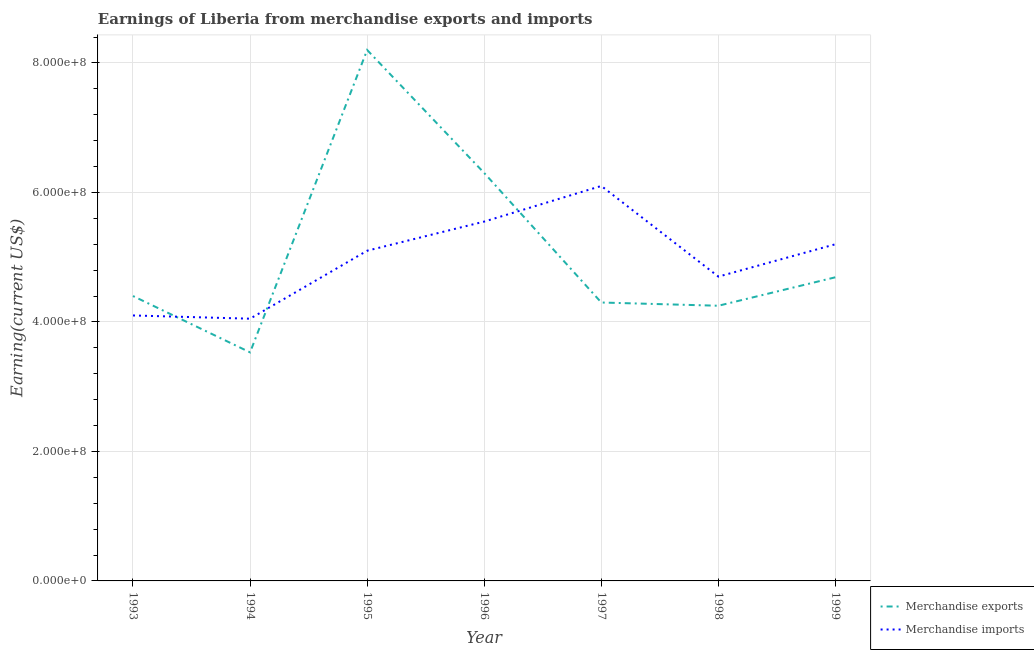How many different coloured lines are there?
Your response must be concise. 2. Is the number of lines equal to the number of legend labels?
Provide a short and direct response. Yes. What is the earnings from merchandise imports in 1993?
Provide a short and direct response. 4.10e+08. Across all years, what is the maximum earnings from merchandise exports?
Your answer should be compact. 8.20e+08. Across all years, what is the minimum earnings from merchandise imports?
Ensure brevity in your answer.  4.05e+08. In which year was the earnings from merchandise exports minimum?
Your response must be concise. 1994. What is the total earnings from merchandise imports in the graph?
Offer a terse response. 3.48e+09. What is the difference between the earnings from merchandise exports in 1997 and that in 1998?
Offer a very short reply. 5.00e+06. What is the difference between the earnings from merchandise imports in 1993 and the earnings from merchandise exports in 1995?
Ensure brevity in your answer.  -4.10e+08. What is the average earnings from merchandise imports per year?
Give a very brief answer. 4.97e+08. In the year 1998, what is the difference between the earnings from merchandise exports and earnings from merchandise imports?
Provide a short and direct response. -4.50e+07. In how many years, is the earnings from merchandise exports greater than 640000000 US$?
Your answer should be very brief. 1. What is the ratio of the earnings from merchandise exports in 1994 to that in 1999?
Provide a succinct answer. 0.75. What is the difference between the highest and the second highest earnings from merchandise imports?
Your answer should be compact. 5.50e+07. What is the difference between the highest and the lowest earnings from merchandise imports?
Your answer should be compact. 2.05e+08. In how many years, is the earnings from merchandise imports greater than the average earnings from merchandise imports taken over all years?
Ensure brevity in your answer.  4. Does the earnings from merchandise exports monotonically increase over the years?
Provide a succinct answer. No. Is the earnings from merchandise exports strictly less than the earnings from merchandise imports over the years?
Offer a very short reply. No. What is the difference between two consecutive major ticks on the Y-axis?
Offer a very short reply. 2.00e+08. Are the values on the major ticks of Y-axis written in scientific E-notation?
Offer a very short reply. Yes. Does the graph contain any zero values?
Your answer should be compact. No. Does the graph contain grids?
Give a very brief answer. Yes. Where does the legend appear in the graph?
Give a very brief answer. Bottom right. What is the title of the graph?
Your response must be concise. Earnings of Liberia from merchandise exports and imports. Does "Rural Population" appear as one of the legend labels in the graph?
Give a very brief answer. No. What is the label or title of the Y-axis?
Keep it short and to the point. Earning(current US$). What is the Earning(current US$) of Merchandise exports in 1993?
Give a very brief answer. 4.40e+08. What is the Earning(current US$) in Merchandise imports in 1993?
Your response must be concise. 4.10e+08. What is the Earning(current US$) of Merchandise exports in 1994?
Ensure brevity in your answer.  3.53e+08. What is the Earning(current US$) in Merchandise imports in 1994?
Provide a short and direct response. 4.05e+08. What is the Earning(current US$) in Merchandise exports in 1995?
Your response must be concise. 8.20e+08. What is the Earning(current US$) in Merchandise imports in 1995?
Offer a terse response. 5.10e+08. What is the Earning(current US$) of Merchandise exports in 1996?
Provide a short and direct response. 6.30e+08. What is the Earning(current US$) in Merchandise imports in 1996?
Ensure brevity in your answer.  5.55e+08. What is the Earning(current US$) of Merchandise exports in 1997?
Provide a succinct answer. 4.30e+08. What is the Earning(current US$) in Merchandise imports in 1997?
Your response must be concise. 6.10e+08. What is the Earning(current US$) in Merchandise exports in 1998?
Your answer should be very brief. 4.25e+08. What is the Earning(current US$) of Merchandise imports in 1998?
Give a very brief answer. 4.70e+08. What is the Earning(current US$) in Merchandise exports in 1999?
Offer a terse response. 4.69e+08. What is the Earning(current US$) of Merchandise imports in 1999?
Give a very brief answer. 5.20e+08. Across all years, what is the maximum Earning(current US$) in Merchandise exports?
Offer a very short reply. 8.20e+08. Across all years, what is the maximum Earning(current US$) in Merchandise imports?
Your answer should be compact. 6.10e+08. Across all years, what is the minimum Earning(current US$) of Merchandise exports?
Offer a terse response. 3.53e+08. Across all years, what is the minimum Earning(current US$) in Merchandise imports?
Your response must be concise. 4.05e+08. What is the total Earning(current US$) of Merchandise exports in the graph?
Your answer should be very brief. 3.57e+09. What is the total Earning(current US$) in Merchandise imports in the graph?
Make the answer very short. 3.48e+09. What is the difference between the Earning(current US$) of Merchandise exports in 1993 and that in 1994?
Give a very brief answer. 8.70e+07. What is the difference between the Earning(current US$) in Merchandise imports in 1993 and that in 1994?
Provide a succinct answer. 5.00e+06. What is the difference between the Earning(current US$) in Merchandise exports in 1993 and that in 1995?
Offer a terse response. -3.80e+08. What is the difference between the Earning(current US$) in Merchandise imports in 1993 and that in 1995?
Offer a very short reply. -1.00e+08. What is the difference between the Earning(current US$) in Merchandise exports in 1993 and that in 1996?
Your answer should be compact. -1.90e+08. What is the difference between the Earning(current US$) of Merchandise imports in 1993 and that in 1996?
Offer a terse response. -1.45e+08. What is the difference between the Earning(current US$) in Merchandise imports in 1993 and that in 1997?
Give a very brief answer. -2.00e+08. What is the difference between the Earning(current US$) in Merchandise exports in 1993 and that in 1998?
Offer a terse response. 1.50e+07. What is the difference between the Earning(current US$) in Merchandise imports in 1993 and that in 1998?
Provide a succinct answer. -6.00e+07. What is the difference between the Earning(current US$) of Merchandise exports in 1993 and that in 1999?
Ensure brevity in your answer.  -2.90e+07. What is the difference between the Earning(current US$) in Merchandise imports in 1993 and that in 1999?
Provide a short and direct response. -1.10e+08. What is the difference between the Earning(current US$) in Merchandise exports in 1994 and that in 1995?
Keep it short and to the point. -4.67e+08. What is the difference between the Earning(current US$) of Merchandise imports in 1994 and that in 1995?
Make the answer very short. -1.05e+08. What is the difference between the Earning(current US$) in Merchandise exports in 1994 and that in 1996?
Provide a succinct answer. -2.77e+08. What is the difference between the Earning(current US$) of Merchandise imports in 1994 and that in 1996?
Your answer should be compact. -1.50e+08. What is the difference between the Earning(current US$) of Merchandise exports in 1994 and that in 1997?
Provide a short and direct response. -7.70e+07. What is the difference between the Earning(current US$) of Merchandise imports in 1994 and that in 1997?
Offer a terse response. -2.05e+08. What is the difference between the Earning(current US$) of Merchandise exports in 1994 and that in 1998?
Your response must be concise. -7.20e+07. What is the difference between the Earning(current US$) of Merchandise imports in 1994 and that in 1998?
Provide a succinct answer. -6.50e+07. What is the difference between the Earning(current US$) in Merchandise exports in 1994 and that in 1999?
Provide a short and direct response. -1.16e+08. What is the difference between the Earning(current US$) in Merchandise imports in 1994 and that in 1999?
Provide a short and direct response. -1.15e+08. What is the difference between the Earning(current US$) in Merchandise exports in 1995 and that in 1996?
Give a very brief answer. 1.90e+08. What is the difference between the Earning(current US$) of Merchandise imports in 1995 and that in 1996?
Make the answer very short. -4.50e+07. What is the difference between the Earning(current US$) of Merchandise exports in 1995 and that in 1997?
Give a very brief answer. 3.90e+08. What is the difference between the Earning(current US$) in Merchandise imports in 1995 and that in 1997?
Provide a succinct answer. -1.00e+08. What is the difference between the Earning(current US$) in Merchandise exports in 1995 and that in 1998?
Your answer should be compact. 3.95e+08. What is the difference between the Earning(current US$) in Merchandise imports in 1995 and that in 1998?
Offer a terse response. 4.00e+07. What is the difference between the Earning(current US$) in Merchandise exports in 1995 and that in 1999?
Provide a succinct answer. 3.51e+08. What is the difference between the Earning(current US$) in Merchandise imports in 1995 and that in 1999?
Provide a succinct answer. -1.00e+07. What is the difference between the Earning(current US$) of Merchandise imports in 1996 and that in 1997?
Offer a terse response. -5.50e+07. What is the difference between the Earning(current US$) in Merchandise exports in 1996 and that in 1998?
Ensure brevity in your answer.  2.05e+08. What is the difference between the Earning(current US$) of Merchandise imports in 1996 and that in 1998?
Offer a very short reply. 8.50e+07. What is the difference between the Earning(current US$) of Merchandise exports in 1996 and that in 1999?
Offer a very short reply. 1.61e+08. What is the difference between the Earning(current US$) in Merchandise imports in 1996 and that in 1999?
Ensure brevity in your answer.  3.50e+07. What is the difference between the Earning(current US$) in Merchandise exports in 1997 and that in 1998?
Provide a short and direct response. 5.00e+06. What is the difference between the Earning(current US$) in Merchandise imports in 1997 and that in 1998?
Make the answer very short. 1.40e+08. What is the difference between the Earning(current US$) in Merchandise exports in 1997 and that in 1999?
Offer a terse response. -3.90e+07. What is the difference between the Earning(current US$) in Merchandise imports in 1997 and that in 1999?
Provide a succinct answer. 9.00e+07. What is the difference between the Earning(current US$) of Merchandise exports in 1998 and that in 1999?
Provide a succinct answer. -4.40e+07. What is the difference between the Earning(current US$) of Merchandise imports in 1998 and that in 1999?
Provide a short and direct response. -5.00e+07. What is the difference between the Earning(current US$) of Merchandise exports in 1993 and the Earning(current US$) of Merchandise imports in 1994?
Your response must be concise. 3.50e+07. What is the difference between the Earning(current US$) of Merchandise exports in 1993 and the Earning(current US$) of Merchandise imports in 1995?
Keep it short and to the point. -7.00e+07. What is the difference between the Earning(current US$) in Merchandise exports in 1993 and the Earning(current US$) in Merchandise imports in 1996?
Your answer should be very brief. -1.15e+08. What is the difference between the Earning(current US$) of Merchandise exports in 1993 and the Earning(current US$) of Merchandise imports in 1997?
Provide a short and direct response. -1.70e+08. What is the difference between the Earning(current US$) of Merchandise exports in 1993 and the Earning(current US$) of Merchandise imports in 1998?
Make the answer very short. -3.00e+07. What is the difference between the Earning(current US$) in Merchandise exports in 1993 and the Earning(current US$) in Merchandise imports in 1999?
Ensure brevity in your answer.  -8.00e+07. What is the difference between the Earning(current US$) in Merchandise exports in 1994 and the Earning(current US$) in Merchandise imports in 1995?
Keep it short and to the point. -1.57e+08. What is the difference between the Earning(current US$) of Merchandise exports in 1994 and the Earning(current US$) of Merchandise imports in 1996?
Give a very brief answer. -2.02e+08. What is the difference between the Earning(current US$) in Merchandise exports in 1994 and the Earning(current US$) in Merchandise imports in 1997?
Keep it short and to the point. -2.57e+08. What is the difference between the Earning(current US$) in Merchandise exports in 1994 and the Earning(current US$) in Merchandise imports in 1998?
Your answer should be very brief. -1.17e+08. What is the difference between the Earning(current US$) of Merchandise exports in 1994 and the Earning(current US$) of Merchandise imports in 1999?
Offer a very short reply. -1.67e+08. What is the difference between the Earning(current US$) in Merchandise exports in 1995 and the Earning(current US$) in Merchandise imports in 1996?
Ensure brevity in your answer.  2.65e+08. What is the difference between the Earning(current US$) of Merchandise exports in 1995 and the Earning(current US$) of Merchandise imports in 1997?
Ensure brevity in your answer.  2.10e+08. What is the difference between the Earning(current US$) in Merchandise exports in 1995 and the Earning(current US$) in Merchandise imports in 1998?
Ensure brevity in your answer.  3.50e+08. What is the difference between the Earning(current US$) of Merchandise exports in 1995 and the Earning(current US$) of Merchandise imports in 1999?
Your response must be concise. 3.00e+08. What is the difference between the Earning(current US$) of Merchandise exports in 1996 and the Earning(current US$) of Merchandise imports in 1998?
Your answer should be very brief. 1.60e+08. What is the difference between the Earning(current US$) of Merchandise exports in 1996 and the Earning(current US$) of Merchandise imports in 1999?
Offer a very short reply. 1.10e+08. What is the difference between the Earning(current US$) of Merchandise exports in 1997 and the Earning(current US$) of Merchandise imports in 1998?
Your response must be concise. -4.00e+07. What is the difference between the Earning(current US$) in Merchandise exports in 1997 and the Earning(current US$) in Merchandise imports in 1999?
Make the answer very short. -9.00e+07. What is the difference between the Earning(current US$) of Merchandise exports in 1998 and the Earning(current US$) of Merchandise imports in 1999?
Keep it short and to the point. -9.50e+07. What is the average Earning(current US$) in Merchandise exports per year?
Give a very brief answer. 5.10e+08. What is the average Earning(current US$) of Merchandise imports per year?
Your answer should be compact. 4.97e+08. In the year 1993, what is the difference between the Earning(current US$) in Merchandise exports and Earning(current US$) in Merchandise imports?
Offer a very short reply. 3.00e+07. In the year 1994, what is the difference between the Earning(current US$) of Merchandise exports and Earning(current US$) of Merchandise imports?
Ensure brevity in your answer.  -5.20e+07. In the year 1995, what is the difference between the Earning(current US$) of Merchandise exports and Earning(current US$) of Merchandise imports?
Provide a succinct answer. 3.10e+08. In the year 1996, what is the difference between the Earning(current US$) in Merchandise exports and Earning(current US$) in Merchandise imports?
Provide a short and direct response. 7.50e+07. In the year 1997, what is the difference between the Earning(current US$) in Merchandise exports and Earning(current US$) in Merchandise imports?
Keep it short and to the point. -1.80e+08. In the year 1998, what is the difference between the Earning(current US$) in Merchandise exports and Earning(current US$) in Merchandise imports?
Provide a succinct answer. -4.50e+07. In the year 1999, what is the difference between the Earning(current US$) in Merchandise exports and Earning(current US$) in Merchandise imports?
Keep it short and to the point. -5.10e+07. What is the ratio of the Earning(current US$) in Merchandise exports in 1993 to that in 1994?
Provide a succinct answer. 1.25. What is the ratio of the Earning(current US$) of Merchandise imports in 1993 to that in 1994?
Ensure brevity in your answer.  1.01. What is the ratio of the Earning(current US$) in Merchandise exports in 1993 to that in 1995?
Ensure brevity in your answer.  0.54. What is the ratio of the Earning(current US$) in Merchandise imports in 1993 to that in 1995?
Your answer should be compact. 0.8. What is the ratio of the Earning(current US$) in Merchandise exports in 1993 to that in 1996?
Offer a very short reply. 0.7. What is the ratio of the Earning(current US$) in Merchandise imports in 1993 to that in 1996?
Keep it short and to the point. 0.74. What is the ratio of the Earning(current US$) of Merchandise exports in 1993 to that in 1997?
Keep it short and to the point. 1.02. What is the ratio of the Earning(current US$) in Merchandise imports in 1993 to that in 1997?
Your response must be concise. 0.67. What is the ratio of the Earning(current US$) in Merchandise exports in 1993 to that in 1998?
Provide a short and direct response. 1.04. What is the ratio of the Earning(current US$) of Merchandise imports in 1993 to that in 1998?
Provide a short and direct response. 0.87. What is the ratio of the Earning(current US$) of Merchandise exports in 1993 to that in 1999?
Your response must be concise. 0.94. What is the ratio of the Earning(current US$) in Merchandise imports in 1993 to that in 1999?
Make the answer very short. 0.79. What is the ratio of the Earning(current US$) of Merchandise exports in 1994 to that in 1995?
Offer a terse response. 0.43. What is the ratio of the Earning(current US$) in Merchandise imports in 1994 to that in 1995?
Provide a succinct answer. 0.79. What is the ratio of the Earning(current US$) of Merchandise exports in 1994 to that in 1996?
Your answer should be very brief. 0.56. What is the ratio of the Earning(current US$) in Merchandise imports in 1994 to that in 1996?
Keep it short and to the point. 0.73. What is the ratio of the Earning(current US$) of Merchandise exports in 1994 to that in 1997?
Give a very brief answer. 0.82. What is the ratio of the Earning(current US$) in Merchandise imports in 1994 to that in 1997?
Keep it short and to the point. 0.66. What is the ratio of the Earning(current US$) in Merchandise exports in 1994 to that in 1998?
Ensure brevity in your answer.  0.83. What is the ratio of the Earning(current US$) in Merchandise imports in 1994 to that in 1998?
Ensure brevity in your answer.  0.86. What is the ratio of the Earning(current US$) in Merchandise exports in 1994 to that in 1999?
Give a very brief answer. 0.75. What is the ratio of the Earning(current US$) of Merchandise imports in 1994 to that in 1999?
Offer a terse response. 0.78. What is the ratio of the Earning(current US$) in Merchandise exports in 1995 to that in 1996?
Provide a succinct answer. 1.3. What is the ratio of the Earning(current US$) in Merchandise imports in 1995 to that in 1996?
Make the answer very short. 0.92. What is the ratio of the Earning(current US$) of Merchandise exports in 1995 to that in 1997?
Ensure brevity in your answer.  1.91. What is the ratio of the Earning(current US$) in Merchandise imports in 1995 to that in 1997?
Your answer should be very brief. 0.84. What is the ratio of the Earning(current US$) in Merchandise exports in 1995 to that in 1998?
Keep it short and to the point. 1.93. What is the ratio of the Earning(current US$) of Merchandise imports in 1995 to that in 1998?
Keep it short and to the point. 1.09. What is the ratio of the Earning(current US$) in Merchandise exports in 1995 to that in 1999?
Offer a terse response. 1.75. What is the ratio of the Earning(current US$) in Merchandise imports in 1995 to that in 1999?
Give a very brief answer. 0.98. What is the ratio of the Earning(current US$) of Merchandise exports in 1996 to that in 1997?
Make the answer very short. 1.47. What is the ratio of the Earning(current US$) of Merchandise imports in 1996 to that in 1997?
Your response must be concise. 0.91. What is the ratio of the Earning(current US$) of Merchandise exports in 1996 to that in 1998?
Offer a terse response. 1.48. What is the ratio of the Earning(current US$) in Merchandise imports in 1996 to that in 1998?
Offer a terse response. 1.18. What is the ratio of the Earning(current US$) in Merchandise exports in 1996 to that in 1999?
Keep it short and to the point. 1.34. What is the ratio of the Earning(current US$) of Merchandise imports in 1996 to that in 1999?
Provide a succinct answer. 1.07. What is the ratio of the Earning(current US$) of Merchandise exports in 1997 to that in 1998?
Ensure brevity in your answer.  1.01. What is the ratio of the Earning(current US$) of Merchandise imports in 1997 to that in 1998?
Ensure brevity in your answer.  1.3. What is the ratio of the Earning(current US$) of Merchandise exports in 1997 to that in 1999?
Your answer should be compact. 0.92. What is the ratio of the Earning(current US$) of Merchandise imports in 1997 to that in 1999?
Keep it short and to the point. 1.17. What is the ratio of the Earning(current US$) in Merchandise exports in 1998 to that in 1999?
Offer a terse response. 0.91. What is the ratio of the Earning(current US$) in Merchandise imports in 1998 to that in 1999?
Your response must be concise. 0.9. What is the difference between the highest and the second highest Earning(current US$) in Merchandise exports?
Keep it short and to the point. 1.90e+08. What is the difference between the highest and the second highest Earning(current US$) of Merchandise imports?
Give a very brief answer. 5.50e+07. What is the difference between the highest and the lowest Earning(current US$) in Merchandise exports?
Provide a succinct answer. 4.67e+08. What is the difference between the highest and the lowest Earning(current US$) in Merchandise imports?
Offer a terse response. 2.05e+08. 